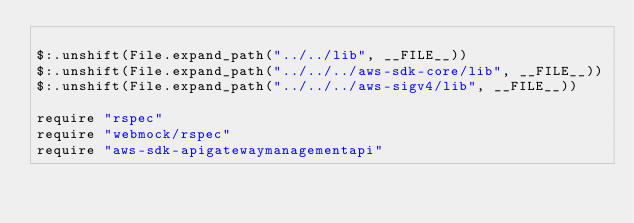<code> <loc_0><loc_0><loc_500><loc_500><_Crystal_>
$:.unshift(File.expand_path("../../lib", __FILE__))
$:.unshift(File.expand_path("../../../aws-sdk-core/lib", __FILE__))
$:.unshift(File.expand_path("../../../aws-sigv4/lib", __FILE__))

require "rspec"
require "webmock/rspec"
require "aws-sdk-apigatewaymanagementapi"
</code> 